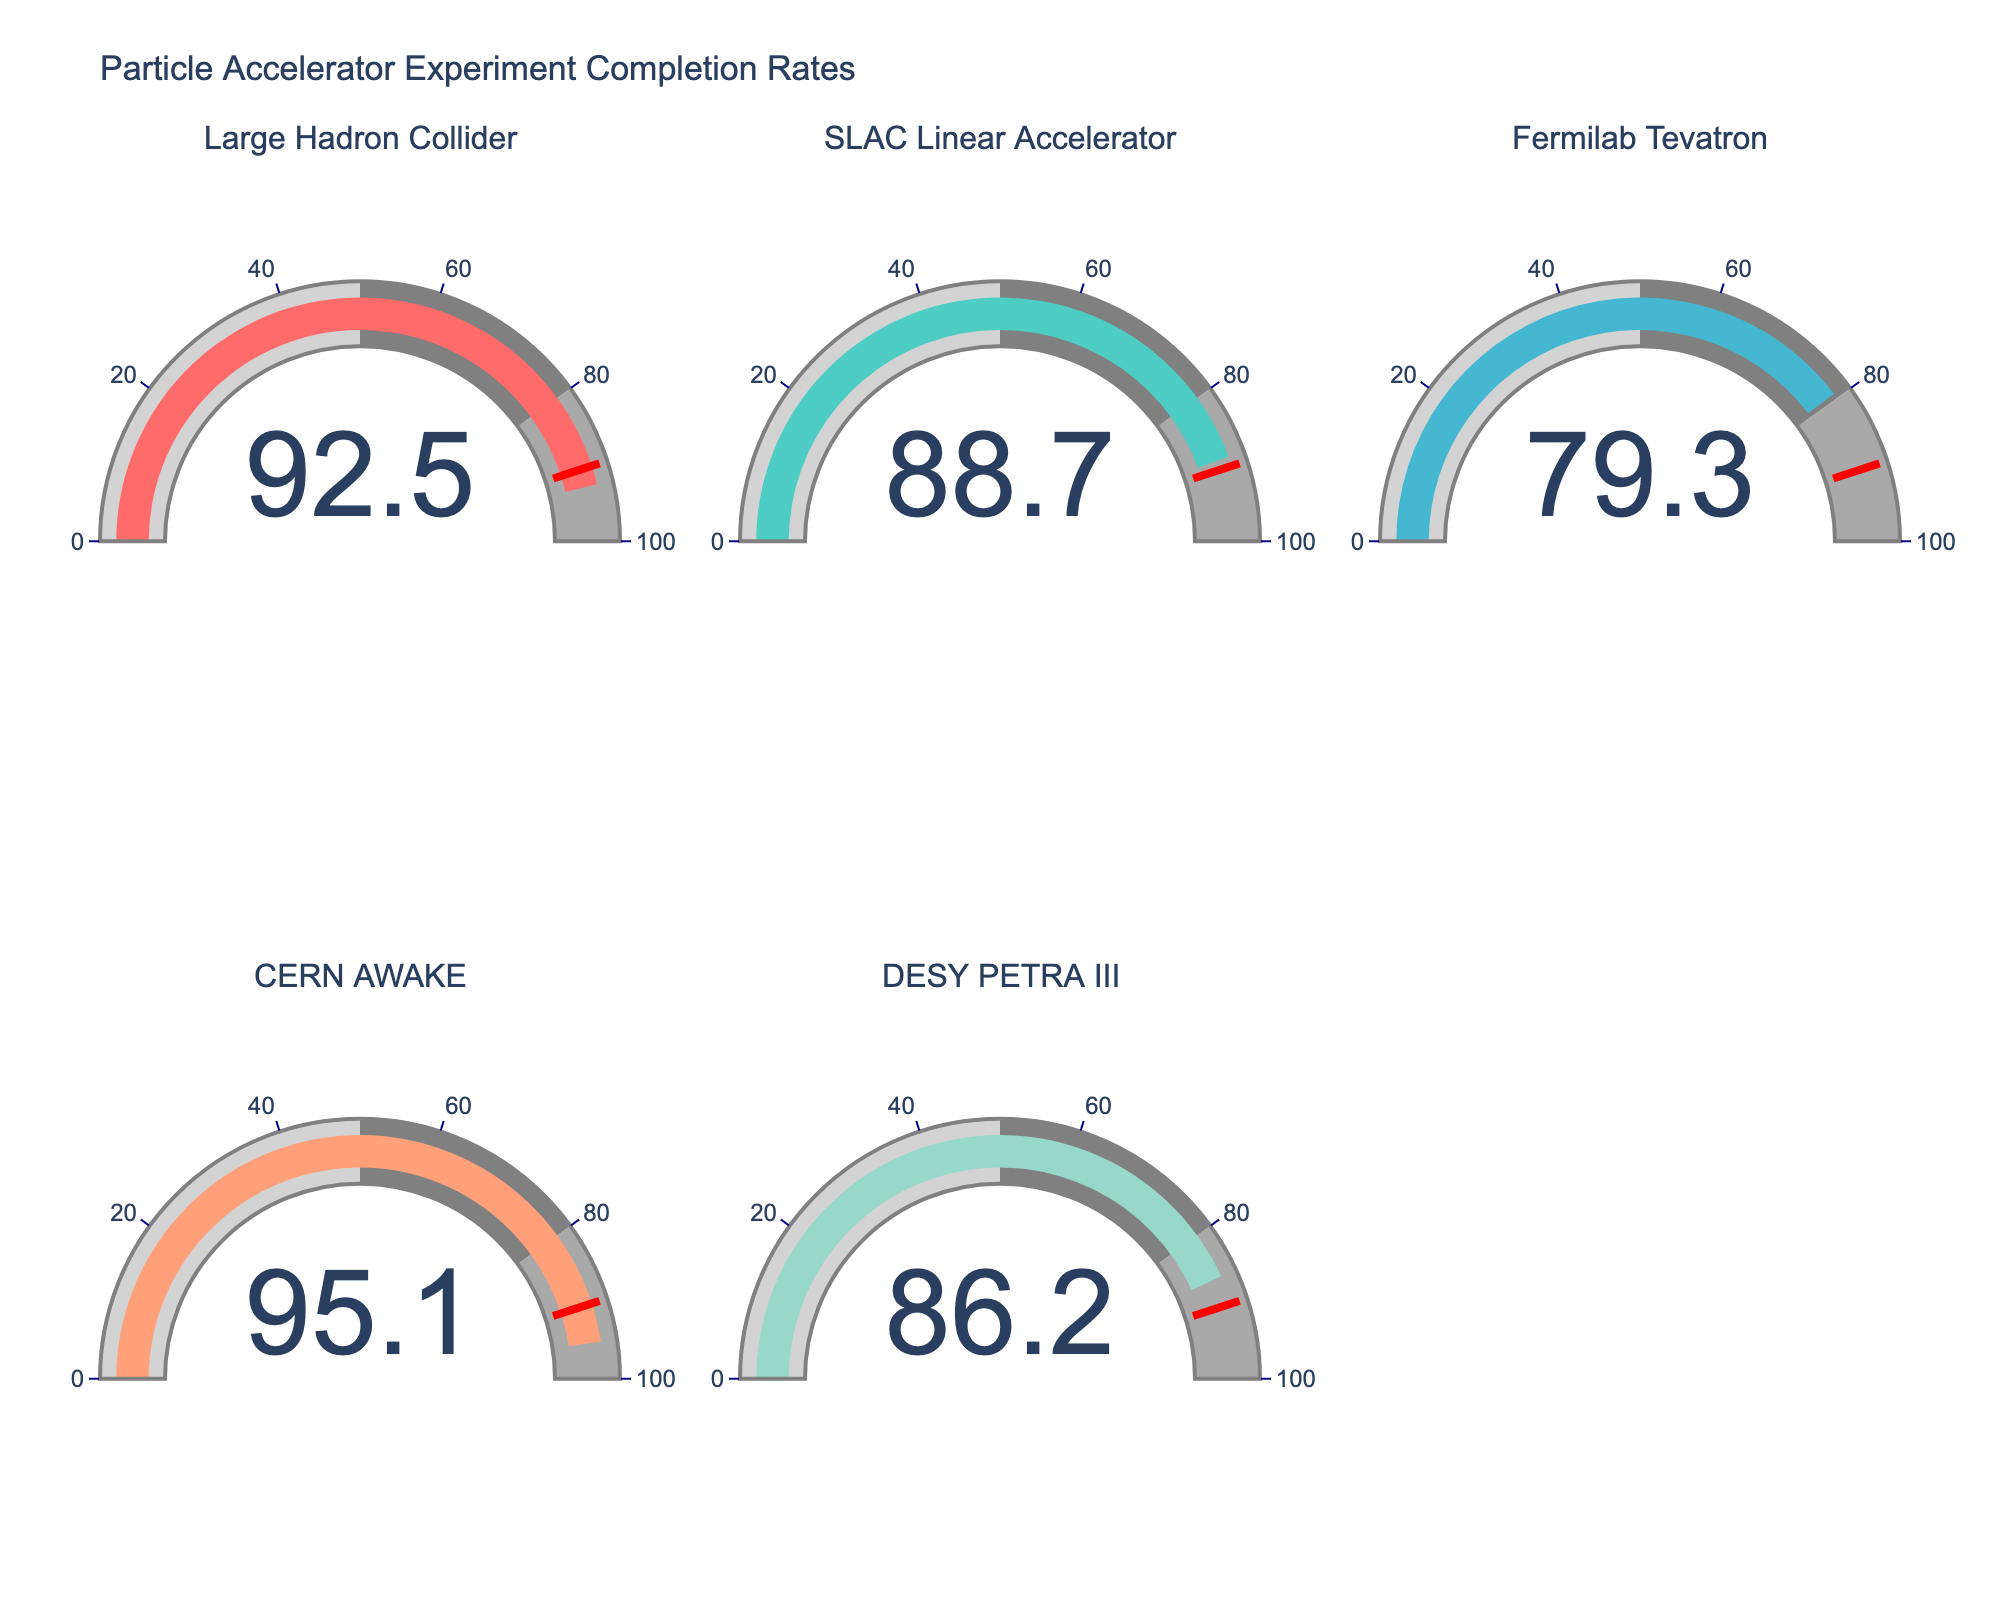How many experiments have a completion rate above 90%? Identify the gauges with values over 90%. There are two such gauges: Large Hadron Collider (92.5) and CERN AWAKE (95.1).
Answer: 2 Which experiment has the lowest completion rate? Compare the values displayed on all gauges. Fermilab Tevatron has the lowest completion rate at 79.3.
Answer: Fermilab Tevatron What is the average completion rate of all the experiments? Add up the completion rates and divide by the number of experiments: (92.5 + 88.7 + 79.3 + 95.1 + 86.2) / 5. The sum is 441.8, so the average completion rate is 441.8 / 5 = 88.36.
Answer: 88.36 How many experiments have a completion rate between 80% and 90%? Count the gauges with values between 80 and 90. SLAC Linear Accelerator (88.7) and DESY PETRA III (86.2) fall into this range.
Answer: 2 Which experiment shows a completion rate closest to the average? The average completion rate is 88.36. Compare this with each individual rate to find the closest: SLAC Linear Accelerator (88.7) is the nearest.
Answer: SLAC Linear Accelerator Which experiment exceeds the threshold of 90% completion rate by the greatest amount? Identify the gauges above 90% and calculate the differences: CERN AWAKE (95.1) exceeds by 5.1, and Large Hadron Collider (92.5) exceeds by 2.5. CERN AWAKE has the greatest difference.
Answer: CERN AWAKE Is the completion rate of DESY PETRA III above or below the average completion rate? Compare DESY PETRA III rate (86.2) with the average (88.36). Since 86.2 is less than 88.36, it is below the average.
Answer: Below What's the difference in completion rate between the highest and lowest experiments? Find the difference between CERN AWAKE (95.1) and Fermilab Tevatron (79.3): 95.1 - 79.3 = 15.8.
Answer: 15.8 Which has a higher completion rate, SLAC Linear Accelerator or Large Hadron Collider? Compare SLAC Linear Accelerator (88.7) with Large Hadron Collider (92.5). The Large Hadron Collider has a higher rate.
Answer: Large Hadron Collider 